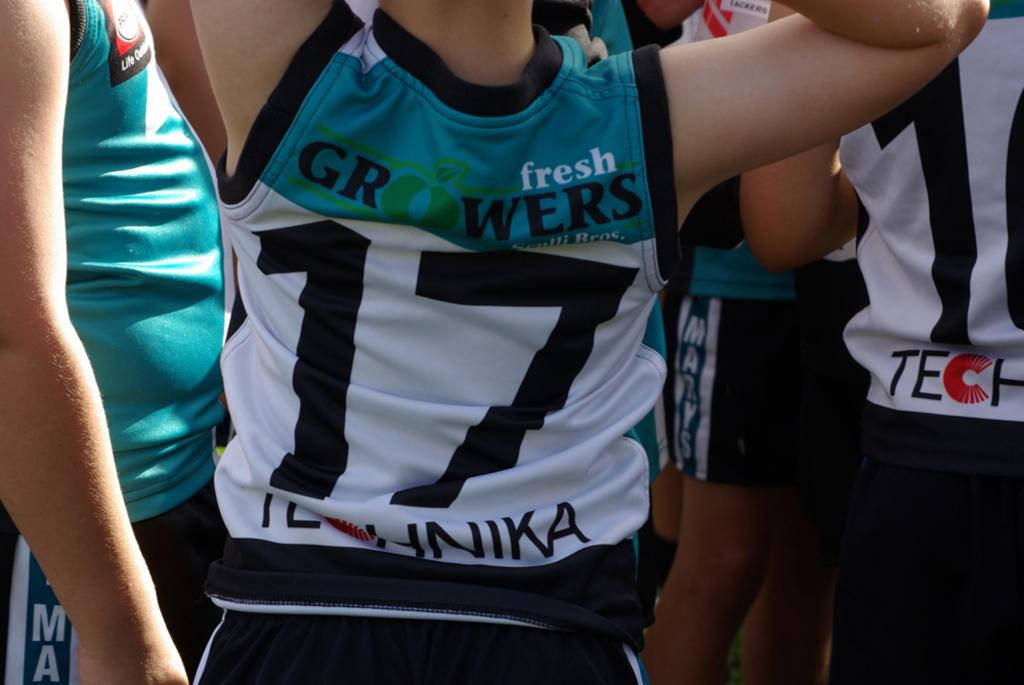<image>
Create a compact narrative representing the image presented. A player wearing a Fresh Growers jersey and the number 17 